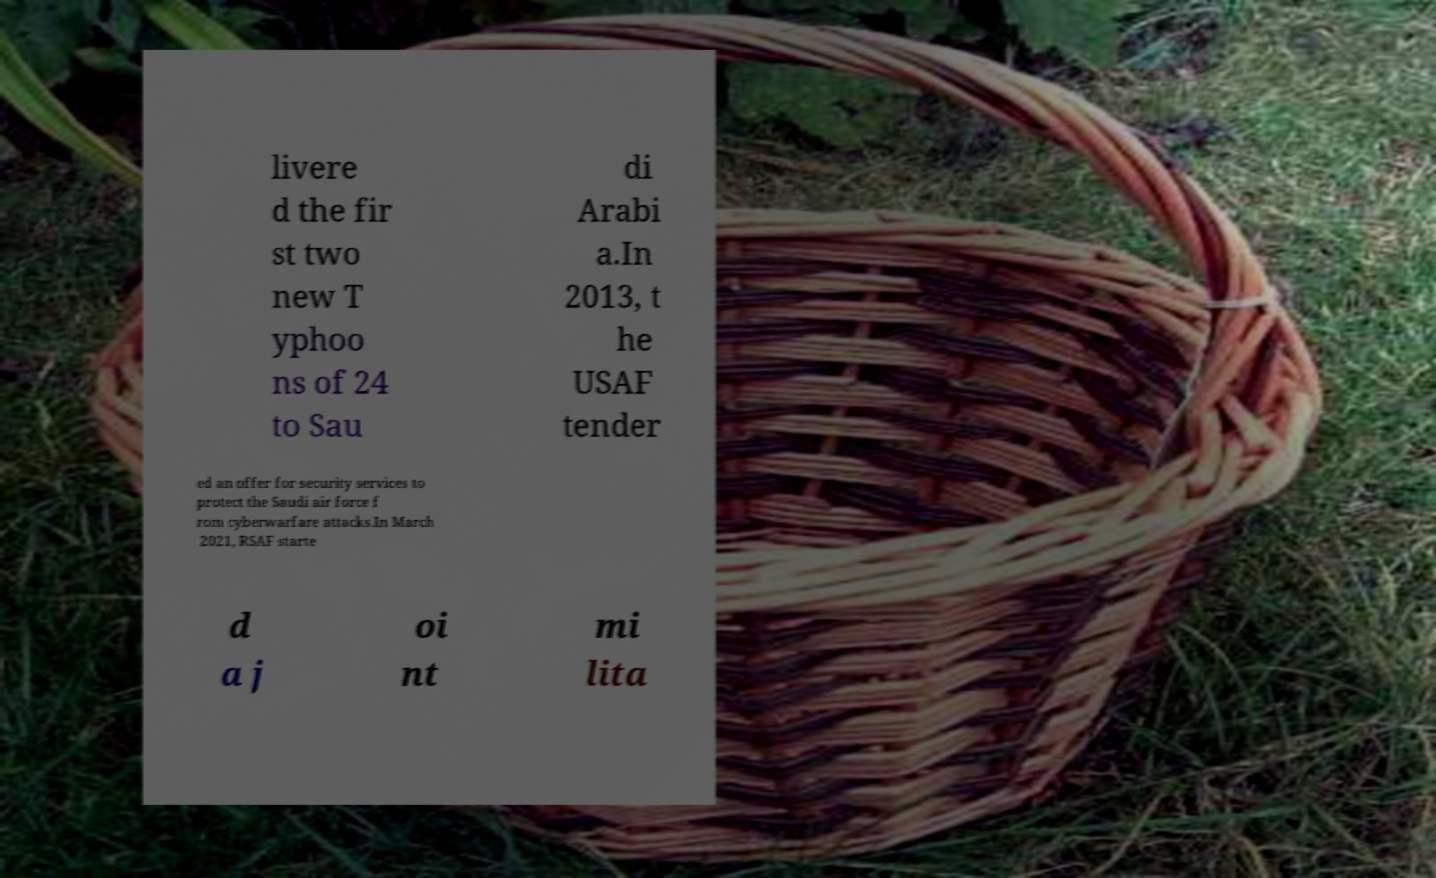Please read and relay the text visible in this image. What does it say? livere d the fir st two new T yphoo ns of 24 to Sau di Arabi a.In 2013, t he USAF tender ed an offer for security services to protect the Saudi air force f rom cyberwarfare attacks.In March 2021, RSAF starte d a j oi nt mi lita 